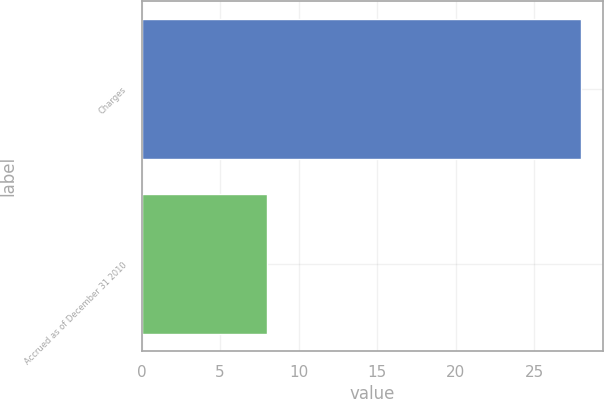<chart> <loc_0><loc_0><loc_500><loc_500><bar_chart><fcel>Charges<fcel>Accrued as of December 31 2010<nl><fcel>28<fcel>8<nl></chart> 